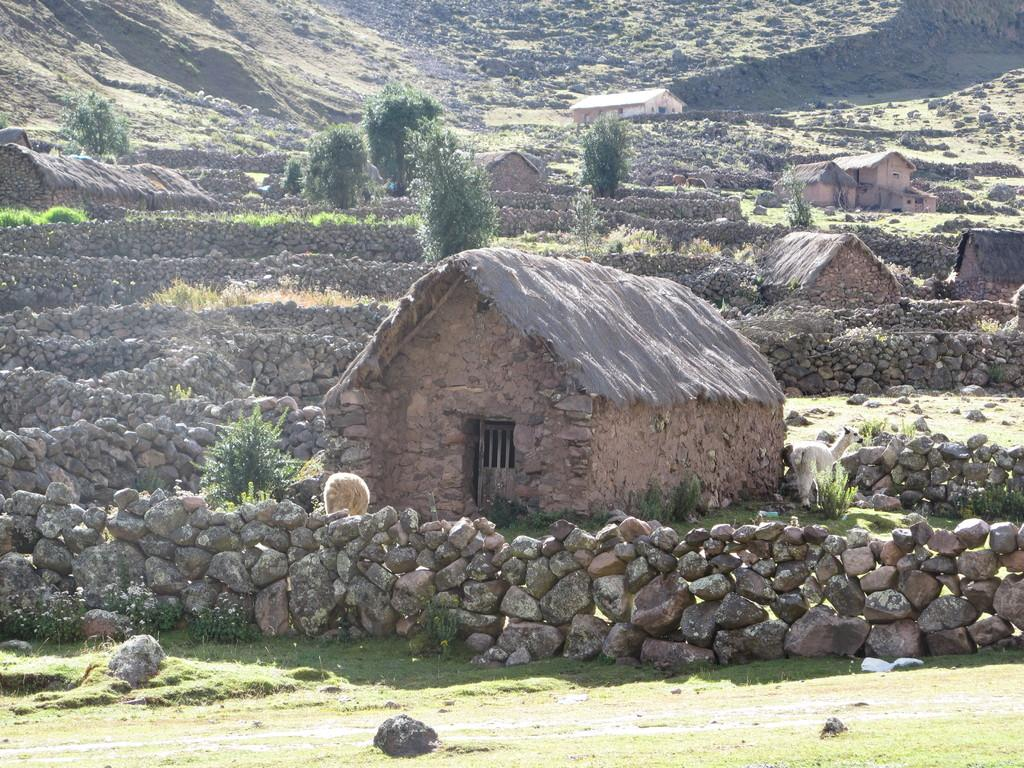What type of structures are present in the image? There are huts in the image. What other natural elements can be seen in the image? There are trees and rocks in the image. Is there any other type of building visible in the image? Yes, there is a house visible in the distance. What is the weight of the church in the image? There is no church present in the image, so it is not possible to determine its weight. 